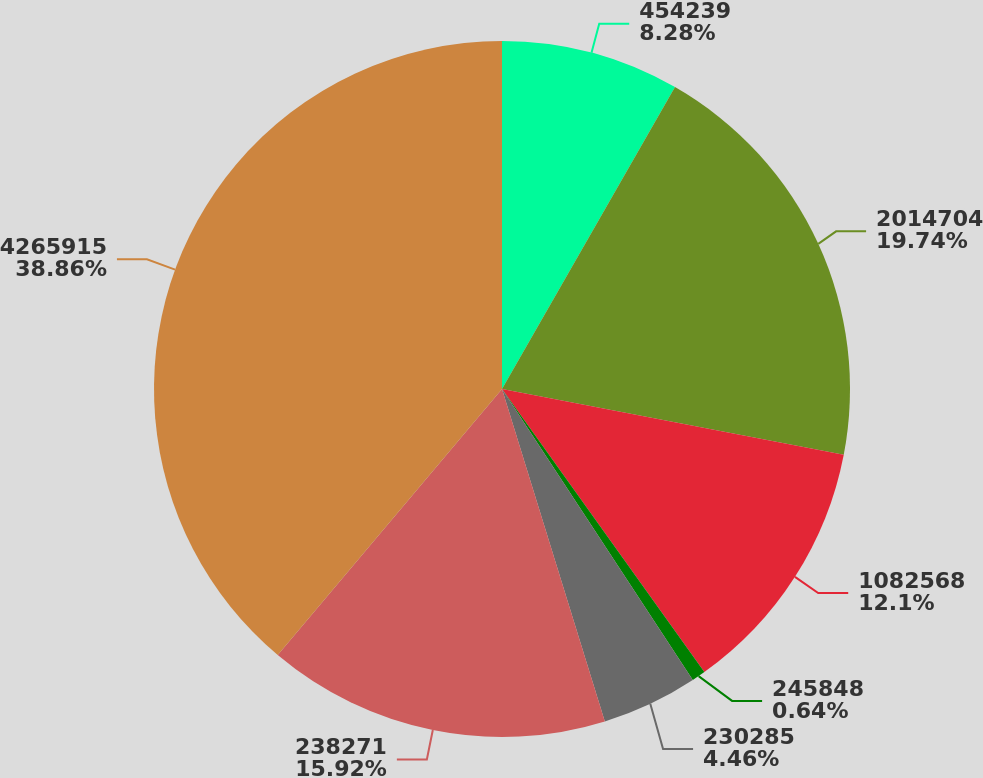Convert chart to OTSL. <chart><loc_0><loc_0><loc_500><loc_500><pie_chart><fcel>454239<fcel>2014704<fcel>1082568<fcel>245848<fcel>230285<fcel>238271<fcel>4265915<nl><fcel>8.28%<fcel>19.74%<fcel>12.1%<fcel>0.64%<fcel>4.46%<fcel>15.92%<fcel>38.85%<nl></chart> 